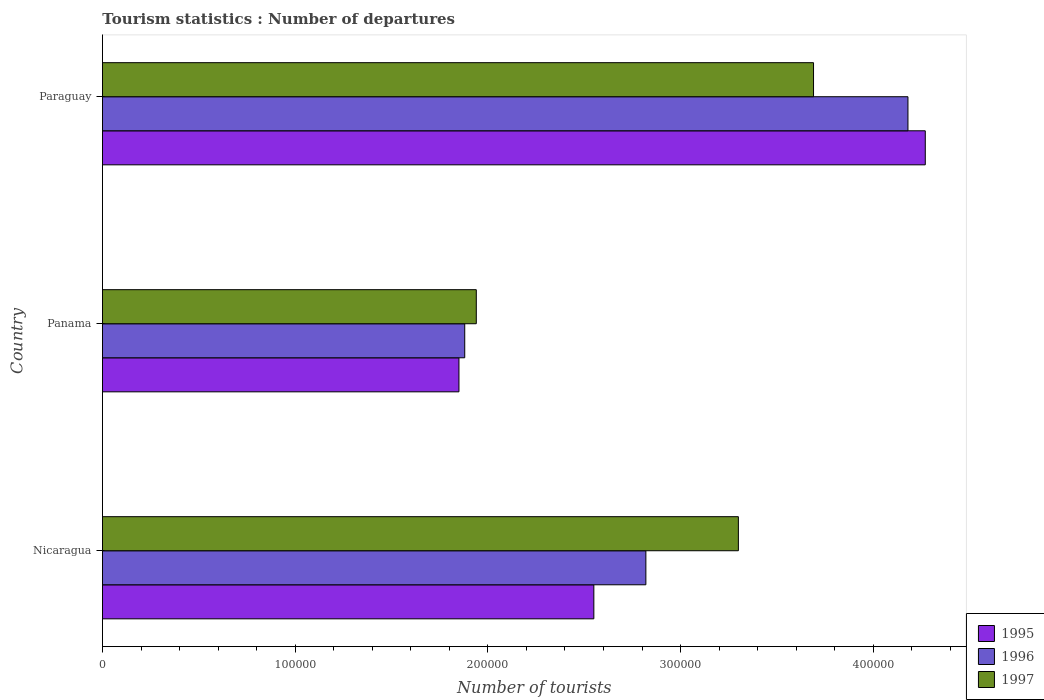How many different coloured bars are there?
Give a very brief answer. 3. Are the number of bars per tick equal to the number of legend labels?
Your response must be concise. Yes. Are the number of bars on each tick of the Y-axis equal?
Your answer should be compact. Yes. What is the label of the 1st group of bars from the top?
Your answer should be compact. Paraguay. What is the number of tourist departures in 1997 in Paraguay?
Ensure brevity in your answer.  3.69e+05. Across all countries, what is the maximum number of tourist departures in 1995?
Offer a very short reply. 4.27e+05. Across all countries, what is the minimum number of tourist departures in 1997?
Provide a succinct answer. 1.94e+05. In which country was the number of tourist departures in 1997 maximum?
Your response must be concise. Paraguay. In which country was the number of tourist departures in 1996 minimum?
Ensure brevity in your answer.  Panama. What is the total number of tourist departures in 1997 in the graph?
Ensure brevity in your answer.  8.93e+05. What is the difference between the number of tourist departures in 1997 in Nicaragua and that in Paraguay?
Your response must be concise. -3.90e+04. What is the difference between the number of tourist departures in 1996 in Panama and the number of tourist departures in 1995 in Paraguay?
Provide a short and direct response. -2.39e+05. What is the average number of tourist departures in 1996 per country?
Your answer should be compact. 2.96e+05. What is the difference between the number of tourist departures in 1996 and number of tourist departures in 1997 in Paraguay?
Keep it short and to the point. 4.90e+04. In how many countries, is the number of tourist departures in 1995 greater than 360000 ?
Keep it short and to the point. 1. What is the ratio of the number of tourist departures in 1996 in Panama to that in Paraguay?
Your answer should be compact. 0.45. What is the difference between the highest and the second highest number of tourist departures in 1996?
Your answer should be compact. 1.36e+05. What is the difference between the highest and the lowest number of tourist departures in 1997?
Provide a succinct answer. 1.75e+05. In how many countries, is the number of tourist departures in 1996 greater than the average number of tourist departures in 1996 taken over all countries?
Provide a short and direct response. 1. Is it the case that in every country, the sum of the number of tourist departures in 1995 and number of tourist departures in 1996 is greater than the number of tourist departures in 1997?
Offer a very short reply. Yes. Are all the bars in the graph horizontal?
Give a very brief answer. Yes. How many countries are there in the graph?
Your response must be concise. 3. Where does the legend appear in the graph?
Your answer should be compact. Bottom right. How are the legend labels stacked?
Offer a very short reply. Vertical. What is the title of the graph?
Offer a very short reply. Tourism statistics : Number of departures. Does "1962" appear as one of the legend labels in the graph?
Provide a short and direct response. No. What is the label or title of the X-axis?
Give a very brief answer. Number of tourists. What is the Number of tourists in 1995 in Nicaragua?
Provide a short and direct response. 2.55e+05. What is the Number of tourists of 1996 in Nicaragua?
Keep it short and to the point. 2.82e+05. What is the Number of tourists in 1995 in Panama?
Offer a terse response. 1.85e+05. What is the Number of tourists in 1996 in Panama?
Your answer should be compact. 1.88e+05. What is the Number of tourists of 1997 in Panama?
Your answer should be compact. 1.94e+05. What is the Number of tourists of 1995 in Paraguay?
Your response must be concise. 4.27e+05. What is the Number of tourists in 1996 in Paraguay?
Your answer should be very brief. 4.18e+05. What is the Number of tourists in 1997 in Paraguay?
Offer a very short reply. 3.69e+05. Across all countries, what is the maximum Number of tourists in 1995?
Ensure brevity in your answer.  4.27e+05. Across all countries, what is the maximum Number of tourists in 1996?
Your answer should be compact. 4.18e+05. Across all countries, what is the maximum Number of tourists of 1997?
Provide a short and direct response. 3.69e+05. Across all countries, what is the minimum Number of tourists in 1995?
Offer a very short reply. 1.85e+05. Across all countries, what is the minimum Number of tourists of 1996?
Ensure brevity in your answer.  1.88e+05. Across all countries, what is the minimum Number of tourists in 1997?
Your response must be concise. 1.94e+05. What is the total Number of tourists of 1995 in the graph?
Offer a terse response. 8.67e+05. What is the total Number of tourists of 1996 in the graph?
Offer a terse response. 8.88e+05. What is the total Number of tourists of 1997 in the graph?
Your answer should be very brief. 8.93e+05. What is the difference between the Number of tourists of 1995 in Nicaragua and that in Panama?
Offer a very short reply. 7.00e+04. What is the difference between the Number of tourists of 1996 in Nicaragua and that in Panama?
Offer a terse response. 9.40e+04. What is the difference between the Number of tourists in 1997 in Nicaragua and that in Panama?
Give a very brief answer. 1.36e+05. What is the difference between the Number of tourists of 1995 in Nicaragua and that in Paraguay?
Your answer should be very brief. -1.72e+05. What is the difference between the Number of tourists in 1996 in Nicaragua and that in Paraguay?
Your answer should be very brief. -1.36e+05. What is the difference between the Number of tourists in 1997 in Nicaragua and that in Paraguay?
Give a very brief answer. -3.90e+04. What is the difference between the Number of tourists in 1995 in Panama and that in Paraguay?
Offer a terse response. -2.42e+05. What is the difference between the Number of tourists in 1997 in Panama and that in Paraguay?
Give a very brief answer. -1.75e+05. What is the difference between the Number of tourists of 1995 in Nicaragua and the Number of tourists of 1996 in Panama?
Provide a succinct answer. 6.70e+04. What is the difference between the Number of tourists in 1995 in Nicaragua and the Number of tourists in 1997 in Panama?
Provide a short and direct response. 6.10e+04. What is the difference between the Number of tourists of 1996 in Nicaragua and the Number of tourists of 1997 in Panama?
Make the answer very short. 8.80e+04. What is the difference between the Number of tourists of 1995 in Nicaragua and the Number of tourists of 1996 in Paraguay?
Your response must be concise. -1.63e+05. What is the difference between the Number of tourists of 1995 in Nicaragua and the Number of tourists of 1997 in Paraguay?
Your response must be concise. -1.14e+05. What is the difference between the Number of tourists in 1996 in Nicaragua and the Number of tourists in 1997 in Paraguay?
Ensure brevity in your answer.  -8.70e+04. What is the difference between the Number of tourists in 1995 in Panama and the Number of tourists in 1996 in Paraguay?
Make the answer very short. -2.33e+05. What is the difference between the Number of tourists in 1995 in Panama and the Number of tourists in 1997 in Paraguay?
Offer a very short reply. -1.84e+05. What is the difference between the Number of tourists in 1996 in Panama and the Number of tourists in 1997 in Paraguay?
Your answer should be very brief. -1.81e+05. What is the average Number of tourists in 1995 per country?
Provide a short and direct response. 2.89e+05. What is the average Number of tourists of 1996 per country?
Offer a terse response. 2.96e+05. What is the average Number of tourists in 1997 per country?
Ensure brevity in your answer.  2.98e+05. What is the difference between the Number of tourists in 1995 and Number of tourists in 1996 in Nicaragua?
Ensure brevity in your answer.  -2.70e+04. What is the difference between the Number of tourists in 1995 and Number of tourists in 1997 in Nicaragua?
Your response must be concise. -7.50e+04. What is the difference between the Number of tourists of 1996 and Number of tourists of 1997 in Nicaragua?
Make the answer very short. -4.80e+04. What is the difference between the Number of tourists of 1995 and Number of tourists of 1996 in Panama?
Give a very brief answer. -3000. What is the difference between the Number of tourists of 1995 and Number of tourists of 1997 in Panama?
Your response must be concise. -9000. What is the difference between the Number of tourists of 1996 and Number of tourists of 1997 in Panama?
Provide a short and direct response. -6000. What is the difference between the Number of tourists in 1995 and Number of tourists in 1996 in Paraguay?
Give a very brief answer. 9000. What is the difference between the Number of tourists of 1995 and Number of tourists of 1997 in Paraguay?
Offer a terse response. 5.80e+04. What is the difference between the Number of tourists in 1996 and Number of tourists in 1997 in Paraguay?
Provide a short and direct response. 4.90e+04. What is the ratio of the Number of tourists of 1995 in Nicaragua to that in Panama?
Offer a very short reply. 1.38. What is the ratio of the Number of tourists of 1997 in Nicaragua to that in Panama?
Offer a terse response. 1.7. What is the ratio of the Number of tourists in 1995 in Nicaragua to that in Paraguay?
Give a very brief answer. 0.6. What is the ratio of the Number of tourists of 1996 in Nicaragua to that in Paraguay?
Your response must be concise. 0.67. What is the ratio of the Number of tourists of 1997 in Nicaragua to that in Paraguay?
Make the answer very short. 0.89. What is the ratio of the Number of tourists in 1995 in Panama to that in Paraguay?
Give a very brief answer. 0.43. What is the ratio of the Number of tourists of 1996 in Panama to that in Paraguay?
Your answer should be very brief. 0.45. What is the ratio of the Number of tourists in 1997 in Panama to that in Paraguay?
Give a very brief answer. 0.53. What is the difference between the highest and the second highest Number of tourists in 1995?
Your answer should be compact. 1.72e+05. What is the difference between the highest and the second highest Number of tourists in 1996?
Make the answer very short. 1.36e+05. What is the difference between the highest and the second highest Number of tourists of 1997?
Provide a succinct answer. 3.90e+04. What is the difference between the highest and the lowest Number of tourists of 1995?
Your answer should be very brief. 2.42e+05. What is the difference between the highest and the lowest Number of tourists in 1997?
Offer a terse response. 1.75e+05. 